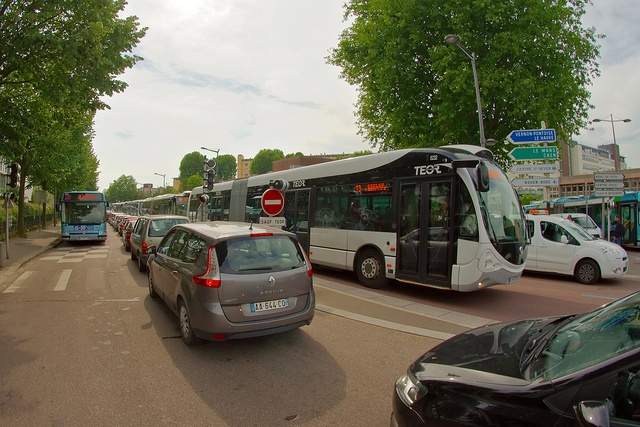Describe the objects in this image and their specific colors. I can see bus in gray, black, and darkgray tones, car in gray, black, darkgray, and teal tones, car in gray, black, and maroon tones, car in gray, darkgray, and black tones, and bus in gray, black, teal, and darkgreen tones in this image. 